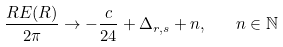<formula> <loc_0><loc_0><loc_500><loc_500>\frac { R E ( R ) } { 2 \pi } \to - \frac { c } { 2 4 } + \Delta _ { r , s } + n , \quad n \in { \mathbb { N } }</formula> 